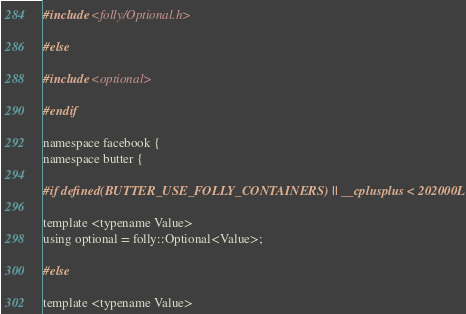<code> <loc_0><loc_0><loc_500><loc_500><_C_>#include <folly/Optional.h>

#else

#include <optional>

#endif

namespace facebook {
namespace butter {

#if defined(BUTTER_USE_FOLLY_CONTAINERS) || __cplusplus < 202000L

template <typename Value>
using optional = folly::Optional<Value>;

#else

template <typename Value></code> 